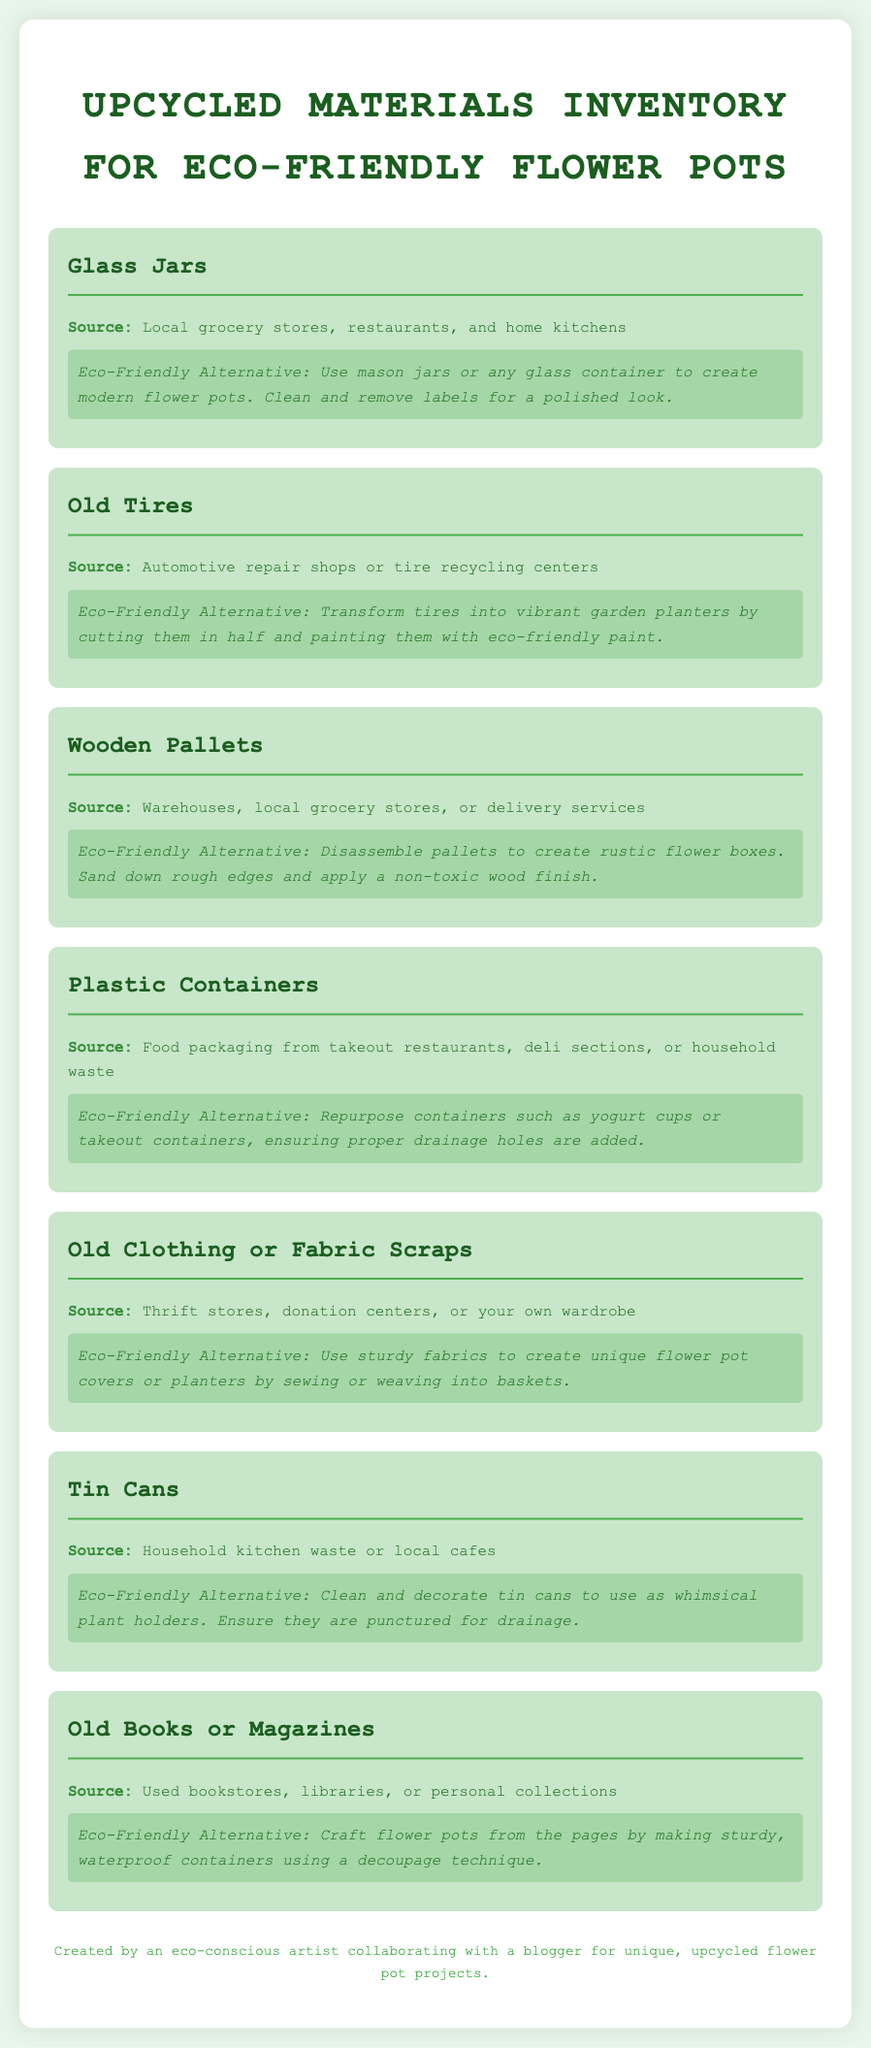What is the main title of the document? The main title is prominently displayed at the top of the document, indicating the subject matter.
Answer: Upcycled Materials Inventory for Eco-Friendly Flower Pots How many types of materials are listed? Each material is presented in a separate section, allowing for easy counting.
Answer: Seven What is the source for glass jars? The document provides specific sources for each material, including glass jars.
Answer: Local grocery stores, restaurants, and home kitchens What eco-friendly alternative is suggested for old tires? Each material has an eco-friendly alternative mentioned, which can be found under each section.
Answer: Transform tires into vibrant garden planters Which material can be repurposed from thrift stores? The document specifies materials and their sources which can be used for projects.
Answer: Old Clothing or Fabric Scraps What is the recommended use for old books or magazines? The document outlines creative uses for upcycled materials, including books.
Answer: Craft flower pots from the pages What kind of finish is suggested for wooden pallets? The document advises on how to treat wooden pallets for upcycled projects.
Answer: Non-toxic wood finish How should tin cans be prepared for use? Specific preparation methods for materials are provided in the corresponding sections.
Answer: Ensure they are punctured for drainage 